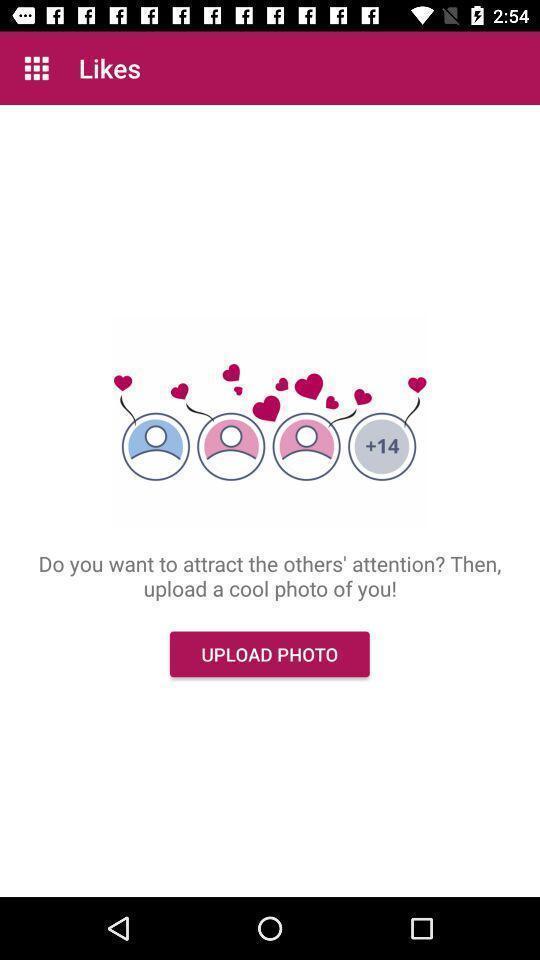Explain the elements present in this screenshot. Screen shows likes page in dating application. 